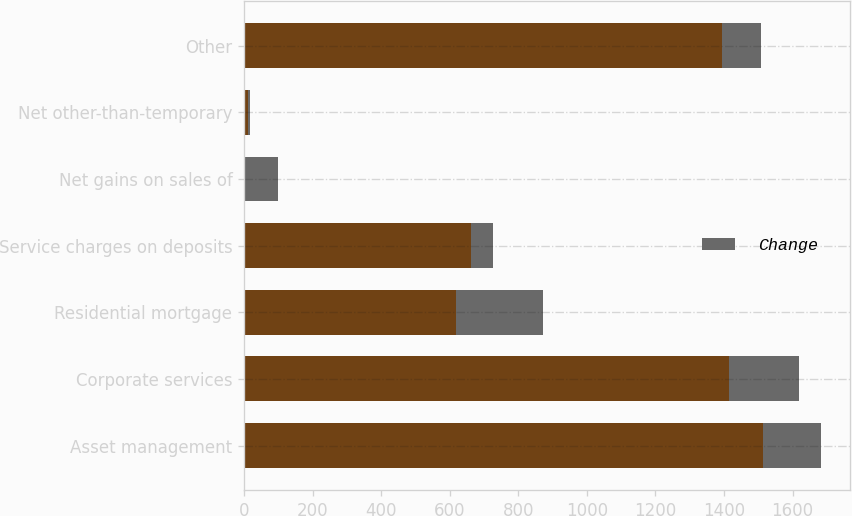Convert chart to OTSL. <chart><loc_0><loc_0><loc_500><loc_500><stacked_bar_chart><ecel><fcel>Asset management<fcel>Corporate services<fcel>Residential mortgage<fcel>Service charges on deposits<fcel>Net gains on sales of<fcel>Net other-than-temporary<fcel>Other<nl><fcel>nan<fcel>1513<fcel>1415<fcel>618<fcel>662<fcel>4<fcel>11<fcel>1395<nl><fcel>Change<fcel>171<fcel>205<fcel>253<fcel>65<fcel>95<fcel>5<fcel>114<nl></chart> 